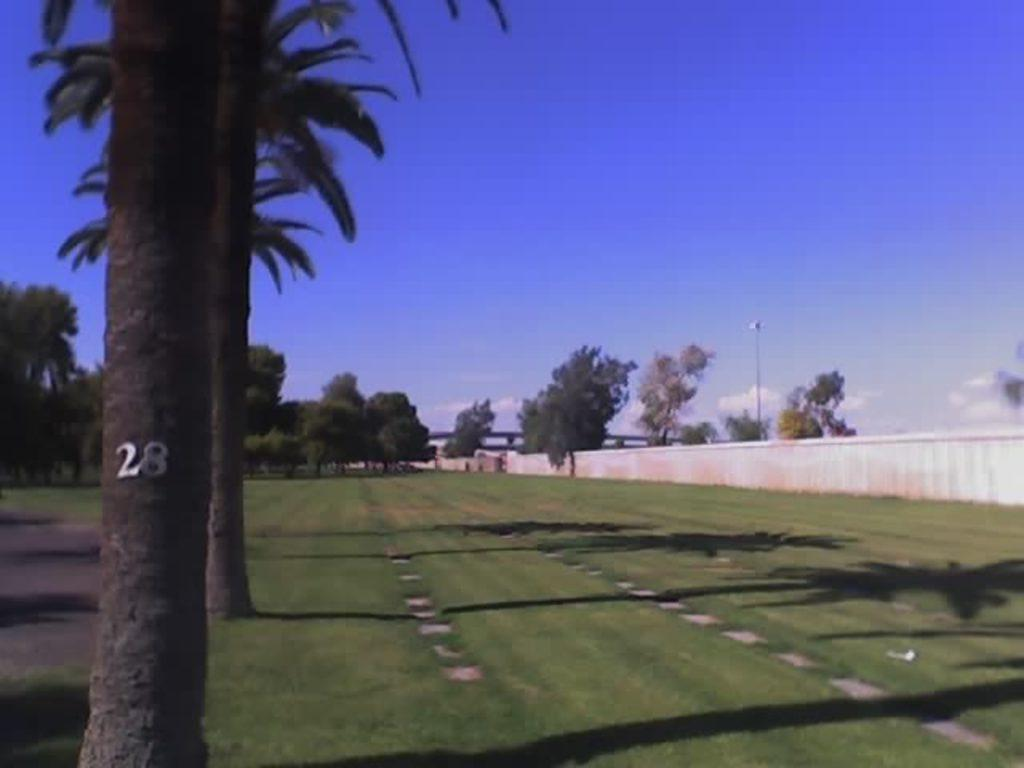What natural elements are in the center of the image? There are trees and grass in the center of the image. What can be seen in the background of the image? Sky, clouds, more trees, and grass are visible in the background of the image. What structures are present in the background of the image? There is a pole and a compound wall in the background of the image. What type of sock is hanging from the tree in the image? There is no sock present in the image; it features trees, grass, and a background with sky, clouds, and a compound wall. 